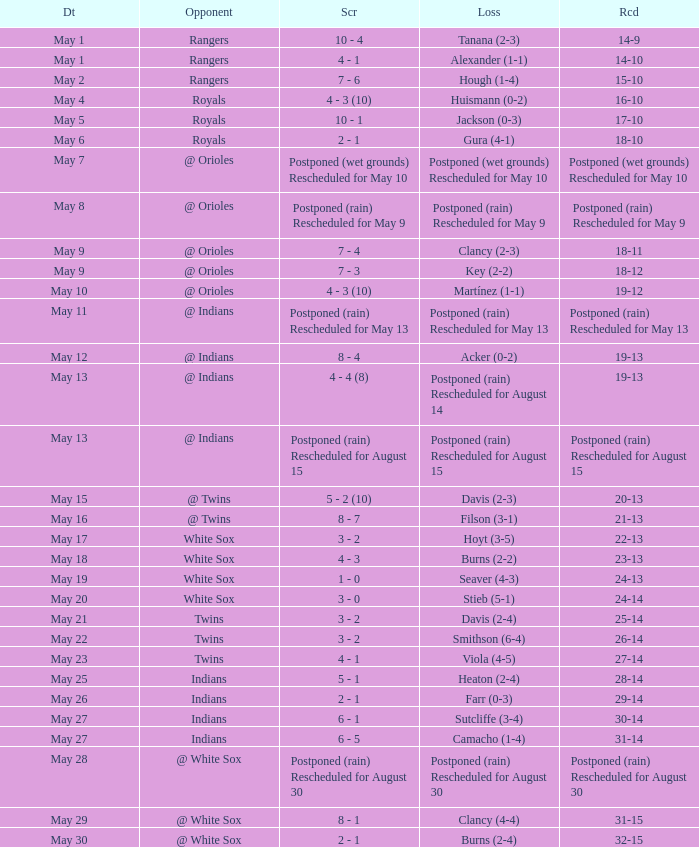What was the loss of the game when the record was 21-13? Filson (3-1). 